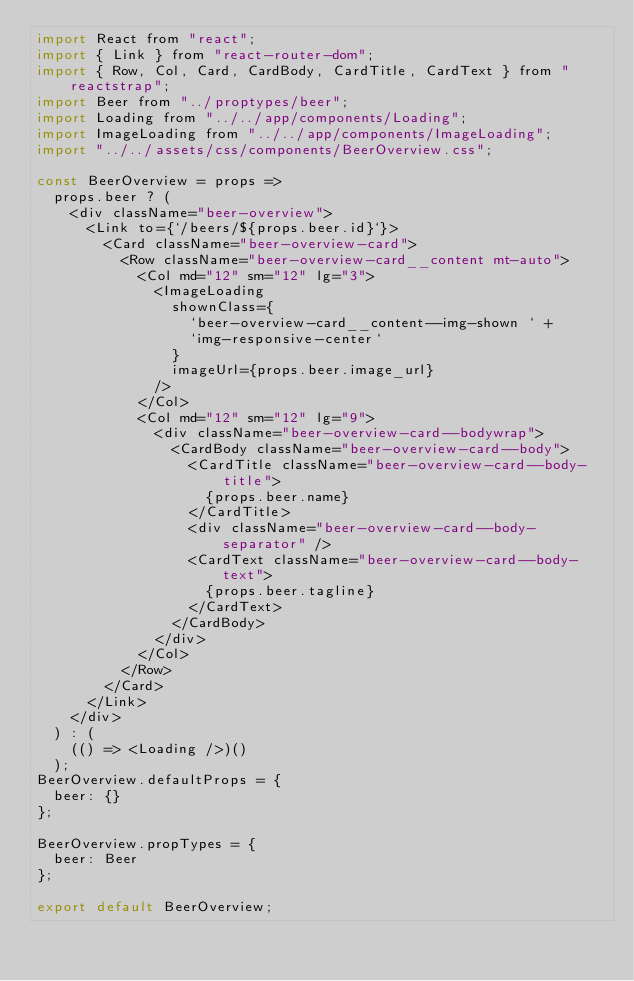Convert code to text. <code><loc_0><loc_0><loc_500><loc_500><_JavaScript_>import React from "react";
import { Link } from "react-router-dom";
import { Row, Col, Card, CardBody, CardTitle, CardText } from "reactstrap";
import Beer from "../proptypes/beer";
import Loading from "../../app/components/Loading";
import ImageLoading from "../../app/components/ImageLoading";
import "../../assets/css/components/BeerOverview.css";

const BeerOverview = props =>
  props.beer ? (
    <div className="beer-overview">
      <Link to={`/beers/${props.beer.id}`}>
        <Card className="beer-overview-card">
          <Row className="beer-overview-card__content mt-auto">
            <Col md="12" sm="12" lg="3">
              <ImageLoading
                shownClass={
                  `beer-overview-card__content--img-shown ` +
                  `img-responsive-center`
                }
                imageUrl={props.beer.image_url}
              />
            </Col>
            <Col md="12" sm="12" lg="9">
              <div className="beer-overview-card--bodywrap">
                <CardBody className="beer-overview-card--body">
                  <CardTitle className="beer-overview-card--body-title">
                    {props.beer.name}
                  </CardTitle>
                  <div className="beer-overview-card--body-separator" />
                  <CardText className="beer-overview-card--body-text">
                    {props.beer.tagline}
                  </CardText>
                </CardBody>
              </div>
            </Col>
          </Row>
        </Card>
      </Link>
    </div>
  ) : (
    (() => <Loading />)()
  );
BeerOverview.defaultProps = {
  beer: {}
};

BeerOverview.propTypes = {
  beer: Beer
};

export default BeerOverview;
</code> 